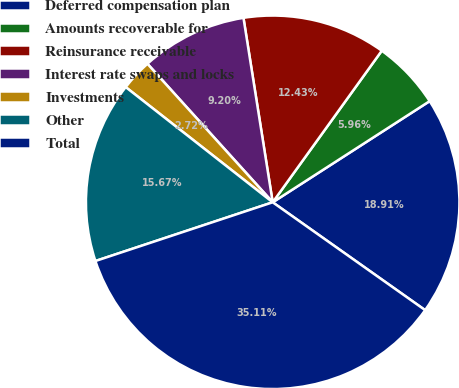Convert chart. <chart><loc_0><loc_0><loc_500><loc_500><pie_chart><fcel>Deferred compensation plan<fcel>Amounts recoverable for<fcel>Reinsurance receivable<fcel>Interest rate swaps and locks<fcel>Investments<fcel>Other<fcel>Total<nl><fcel>18.91%<fcel>5.96%<fcel>12.43%<fcel>9.2%<fcel>2.72%<fcel>15.67%<fcel>35.11%<nl></chart> 